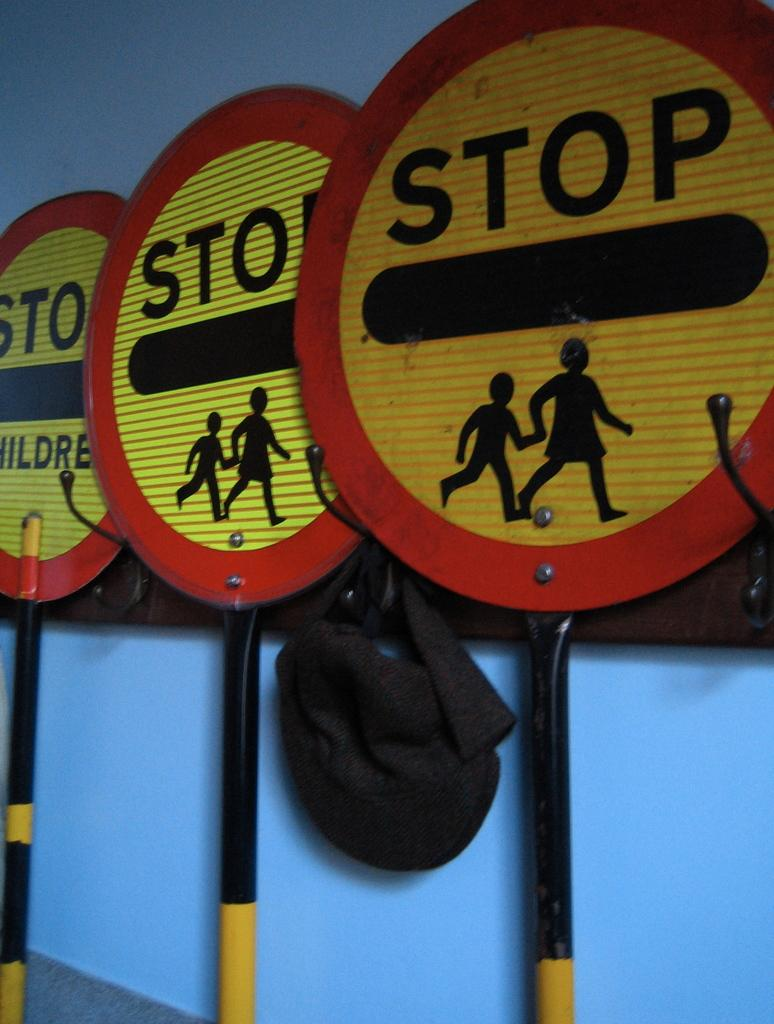Provide a one-sentence caption for the provided image. THREE ROUND STOP SIGNS WITH FIGURES OF CHILDREN. 